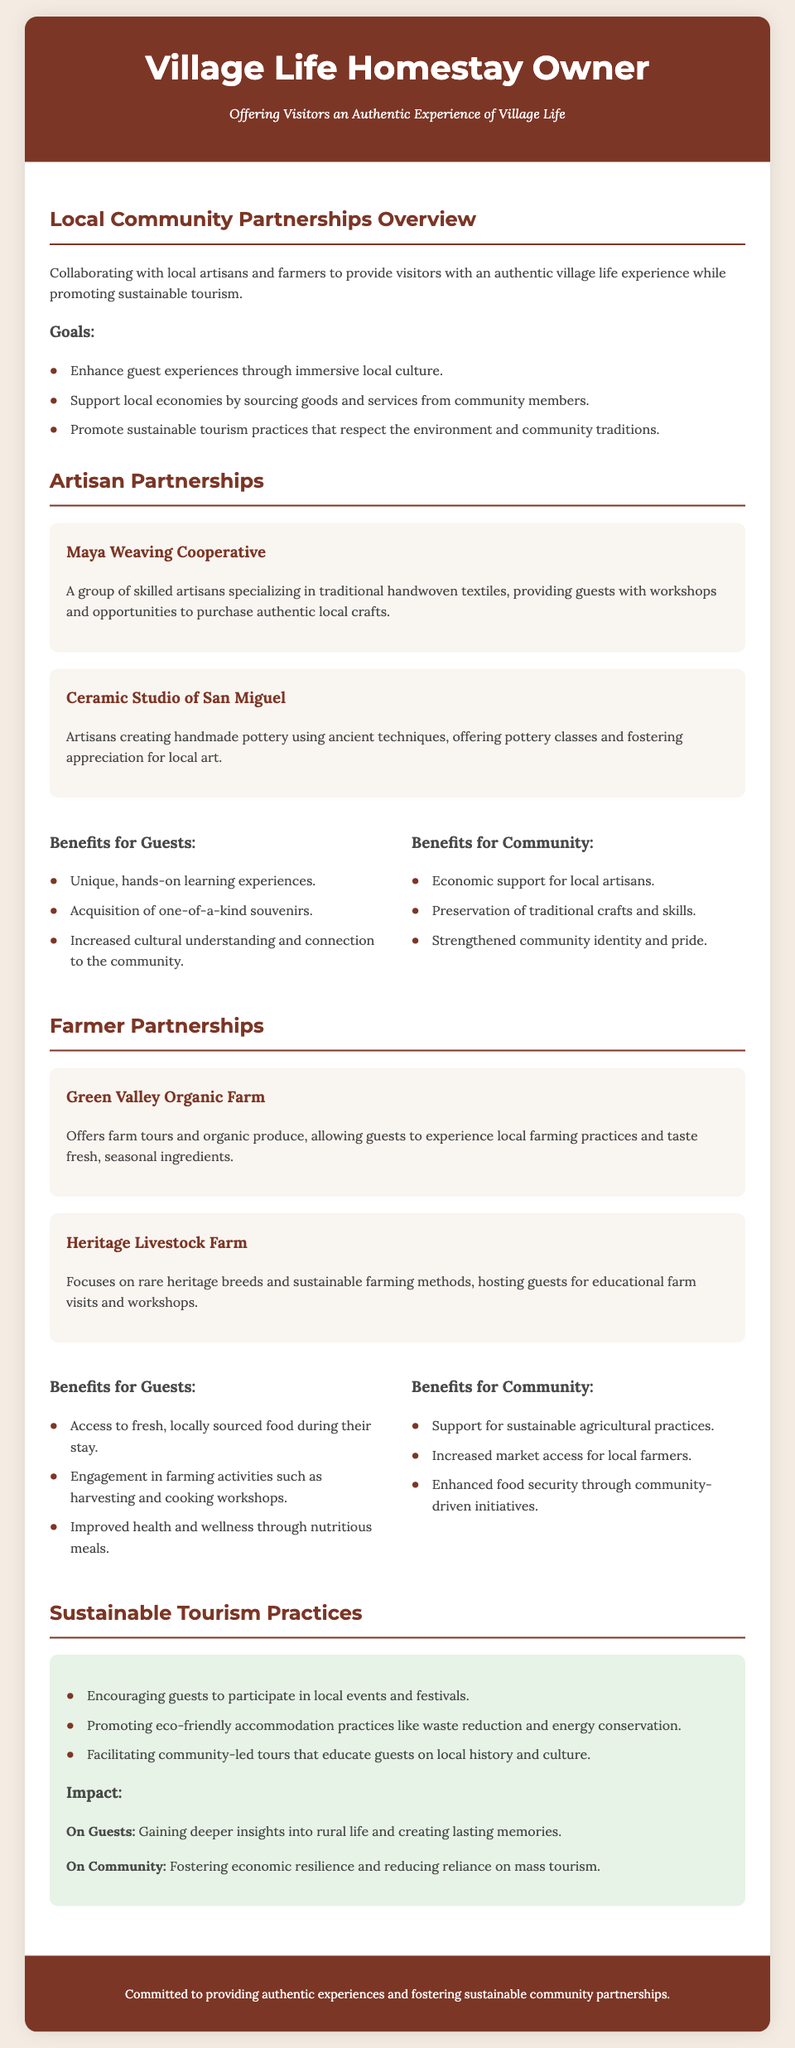What are the goals of local community partnerships? The goals include enhancing guest experiences, supporting local economies, and promoting sustainable tourism practices.
Answer: Enhance guest experiences through immersive local culture, support local economies by sourcing goods and services from community members, promote sustainable tourism practices that respect the environment and community traditions What is the name of the weaving cooperative mentioned? The document specifies a local artisan group called the Maya Weaving Cooperative.
Answer: Maya Weaving Cooperative What type of classes do the artisans at the Ceramic Studio offer? The artisans create handmade pottery and provide pottery classes to guests.
Answer: Pottery classes What farm is associated with organic produce offerings? The Green Valley Organic Farm is noted for providing organic produce and farm tours.
Answer: Green Valley Organic Farm What are the benefits of farmer partnerships for guests? The benefits for guests include access to fresh food, engagement in farming activities, and improved health.
Answer: Access to fresh, locally sourced food during their stay, engagement in farming activities such as harvesting and cooking workshops, improved health and wellness through nutritious meals How does the document suggest guests can participate in local events? It encourages participation in local events and festivals to promote community engagement.
Answer: Encouraging guests to participate in local events and festivals What is the impact of sustainable tourism on guests? Guests gain deeper insights into rural life, contributing to their experience.
Answer: Gaining deeper insights into rural life and creating lasting memories What statement summarizes the commitment described in the footer? The footer indicates a commitment to providing authentic experiences and fostering community partnerships.
Answer: Committed to providing authentic experiences and fostering sustainable community partnerships 